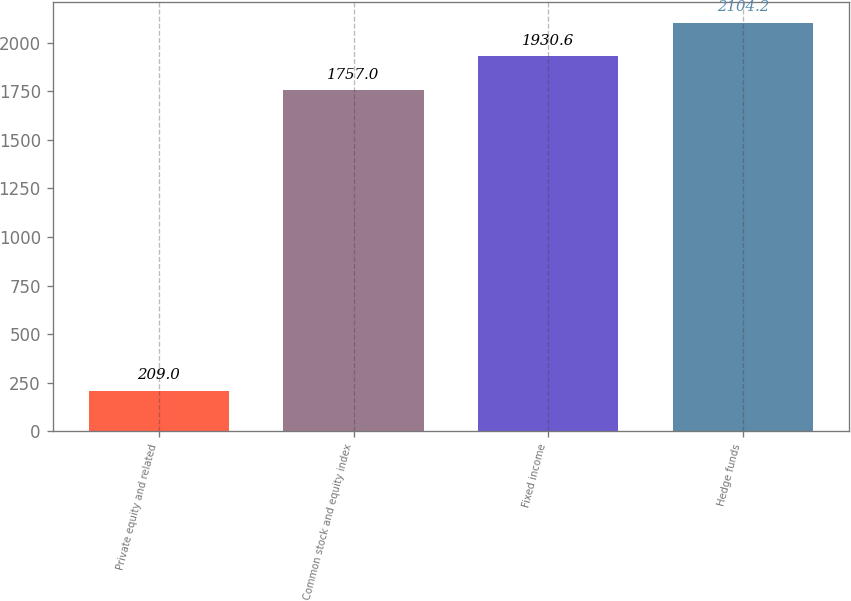Convert chart to OTSL. <chart><loc_0><loc_0><loc_500><loc_500><bar_chart><fcel>Private equity and related<fcel>Common stock and equity index<fcel>Fixed income<fcel>Hedge funds<nl><fcel>209<fcel>1757<fcel>1930.6<fcel>2104.2<nl></chart> 